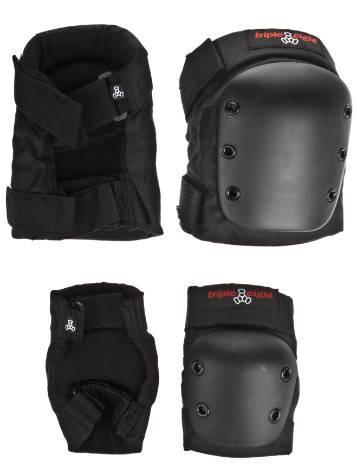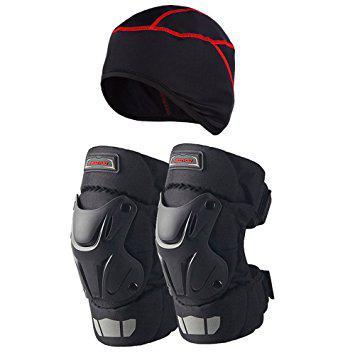The first image is the image on the left, the second image is the image on the right. Evaluate the accuracy of this statement regarding the images: "At least one of the images has a human model wearing the item.". Is it true? Answer yes or no. No. The first image is the image on the left, the second image is the image on the right. Considering the images on both sides, is "One image shows someone wearing at least one of the knee pads." valid? Answer yes or no. No. 